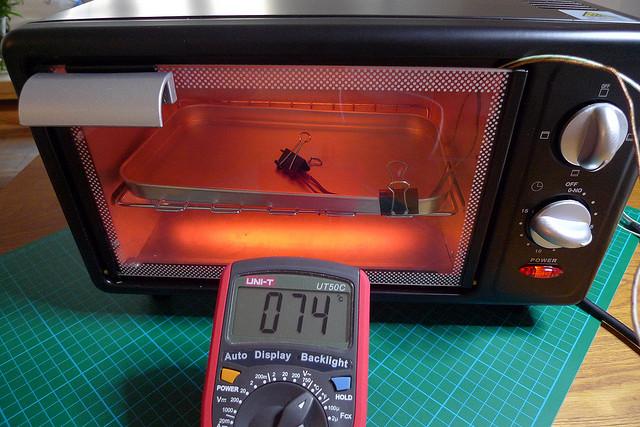Is this safe?
Concise answer only. No. What are the devices holding the leads called?
Concise answer only. Paper clips. What number is seen on the image?
Give a very brief answer. 074. 